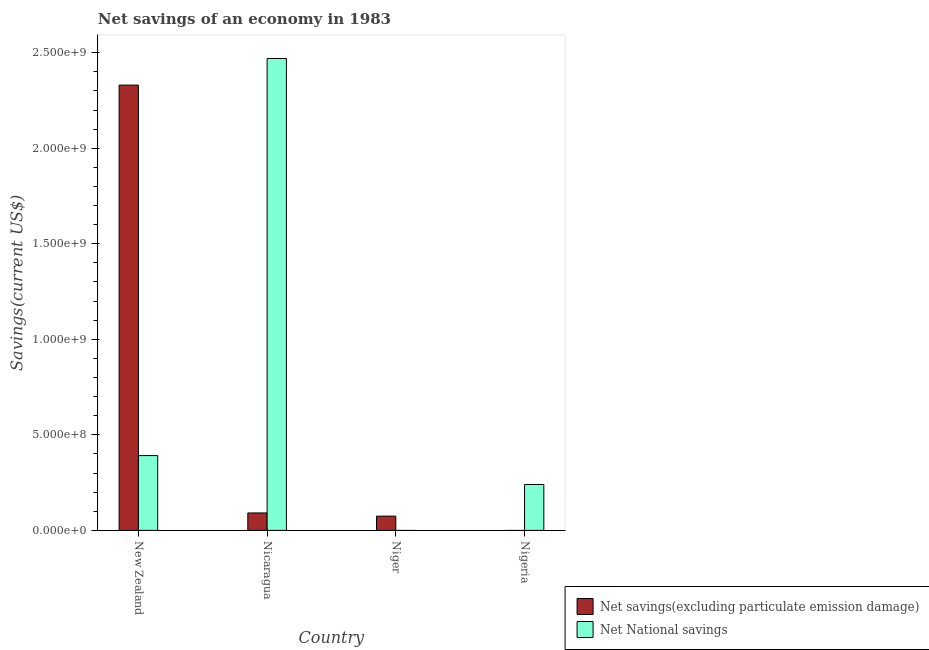Are the number of bars per tick equal to the number of legend labels?
Ensure brevity in your answer.  No. How many bars are there on the 4th tick from the left?
Offer a very short reply. 1. How many bars are there on the 3rd tick from the right?
Offer a very short reply. 2. What is the label of the 4th group of bars from the left?
Your answer should be very brief. Nigeria. What is the net savings(excluding particulate emission damage) in Niger?
Ensure brevity in your answer.  7.47e+07. Across all countries, what is the maximum net national savings?
Make the answer very short. 2.47e+09. In which country was the net national savings maximum?
Offer a terse response. Nicaragua. What is the total net national savings in the graph?
Ensure brevity in your answer.  3.10e+09. What is the difference between the net national savings in Nicaragua and that in Nigeria?
Your answer should be compact. 2.23e+09. What is the difference between the net savings(excluding particulate emission damage) in Niger and the net national savings in New Zealand?
Ensure brevity in your answer.  -3.17e+08. What is the average net national savings per country?
Your answer should be compact. 7.75e+08. What is the difference between the net savings(excluding particulate emission damage) and net national savings in Nicaragua?
Give a very brief answer. -2.38e+09. What is the ratio of the net savings(excluding particulate emission damage) in Nicaragua to that in Niger?
Keep it short and to the point. 1.22. Is the net savings(excluding particulate emission damage) in Nicaragua less than that in Niger?
Make the answer very short. No. What is the difference between the highest and the second highest net national savings?
Keep it short and to the point. 2.08e+09. What is the difference between the highest and the lowest net national savings?
Provide a short and direct response. 2.47e+09. In how many countries, is the net savings(excluding particulate emission damage) greater than the average net savings(excluding particulate emission damage) taken over all countries?
Make the answer very short. 1. How many bars are there?
Keep it short and to the point. 6. What is the difference between two consecutive major ticks on the Y-axis?
Provide a short and direct response. 5.00e+08. Does the graph contain grids?
Your response must be concise. No. What is the title of the graph?
Your answer should be compact. Net savings of an economy in 1983. What is the label or title of the X-axis?
Ensure brevity in your answer.  Country. What is the label or title of the Y-axis?
Provide a succinct answer. Savings(current US$). What is the Savings(current US$) of Net savings(excluding particulate emission damage) in New Zealand?
Provide a succinct answer. 2.33e+09. What is the Savings(current US$) in Net National savings in New Zealand?
Ensure brevity in your answer.  3.92e+08. What is the Savings(current US$) in Net savings(excluding particulate emission damage) in Nicaragua?
Offer a terse response. 9.13e+07. What is the Savings(current US$) in Net National savings in Nicaragua?
Offer a very short reply. 2.47e+09. What is the Savings(current US$) of Net savings(excluding particulate emission damage) in Niger?
Your answer should be very brief. 7.47e+07. What is the Savings(current US$) of Net National savings in Nigeria?
Offer a terse response. 2.40e+08. Across all countries, what is the maximum Savings(current US$) in Net savings(excluding particulate emission damage)?
Offer a very short reply. 2.33e+09. Across all countries, what is the maximum Savings(current US$) in Net National savings?
Provide a short and direct response. 2.47e+09. Across all countries, what is the minimum Savings(current US$) in Net savings(excluding particulate emission damage)?
Your answer should be very brief. 0. Across all countries, what is the minimum Savings(current US$) in Net National savings?
Provide a short and direct response. 0. What is the total Savings(current US$) in Net savings(excluding particulate emission damage) in the graph?
Offer a terse response. 2.50e+09. What is the total Savings(current US$) in Net National savings in the graph?
Your response must be concise. 3.10e+09. What is the difference between the Savings(current US$) of Net savings(excluding particulate emission damage) in New Zealand and that in Nicaragua?
Make the answer very short. 2.24e+09. What is the difference between the Savings(current US$) in Net National savings in New Zealand and that in Nicaragua?
Offer a very short reply. -2.08e+09. What is the difference between the Savings(current US$) of Net savings(excluding particulate emission damage) in New Zealand and that in Niger?
Your answer should be very brief. 2.26e+09. What is the difference between the Savings(current US$) in Net National savings in New Zealand and that in Nigeria?
Your response must be concise. 1.51e+08. What is the difference between the Savings(current US$) in Net savings(excluding particulate emission damage) in Nicaragua and that in Niger?
Give a very brief answer. 1.66e+07. What is the difference between the Savings(current US$) in Net National savings in Nicaragua and that in Nigeria?
Give a very brief answer. 2.23e+09. What is the difference between the Savings(current US$) of Net savings(excluding particulate emission damage) in New Zealand and the Savings(current US$) of Net National savings in Nicaragua?
Offer a very short reply. -1.39e+08. What is the difference between the Savings(current US$) in Net savings(excluding particulate emission damage) in New Zealand and the Savings(current US$) in Net National savings in Nigeria?
Your response must be concise. 2.09e+09. What is the difference between the Savings(current US$) of Net savings(excluding particulate emission damage) in Nicaragua and the Savings(current US$) of Net National savings in Nigeria?
Provide a short and direct response. -1.49e+08. What is the difference between the Savings(current US$) in Net savings(excluding particulate emission damage) in Niger and the Savings(current US$) in Net National savings in Nigeria?
Give a very brief answer. -1.66e+08. What is the average Savings(current US$) in Net savings(excluding particulate emission damage) per country?
Make the answer very short. 6.24e+08. What is the average Savings(current US$) of Net National savings per country?
Provide a short and direct response. 7.75e+08. What is the difference between the Savings(current US$) in Net savings(excluding particulate emission damage) and Savings(current US$) in Net National savings in New Zealand?
Your answer should be very brief. 1.94e+09. What is the difference between the Savings(current US$) of Net savings(excluding particulate emission damage) and Savings(current US$) of Net National savings in Nicaragua?
Offer a terse response. -2.38e+09. What is the ratio of the Savings(current US$) in Net savings(excluding particulate emission damage) in New Zealand to that in Nicaragua?
Offer a very short reply. 25.53. What is the ratio of the Savings(current US$) of Net National savings in New Zealand to that in Nicaragua?
Your answer should be very brief. 0.16. What is the ratio of the Savings(current US$) of Net savings(excluding particulate emission damage) in New Zealand to that in Niger?
Your answer should be very brief. 31.22. What is the ratio of the Savings(current US$) in Net National savings in New Zealand to that in Nigeria?
Provide a short and direct response. 1.63. What is the ratio of the Savings(current US$) of Net savings(excluding particulate emission damage) in Nicaragua to that in Niger?
Ensure brevity in your answer.  1.22. What is the ratio of the Savings(current US$) of Net National savings in Nicaragua to that in Nigeria?
Ensure brevity in your answer.  10.28. What is the difference between the highest and the second highest Savings(current US$) of Net savings(excluding particulate emission damage)?
Your response must be concise. 2.24e+09. What is the difference between the highest and the second highest Savings(current US$) in Net National savings?
Keep it short and to the point. 2.08e+09. What is the difference between the highest and the lowest Savings(current US$) of Net savings(excluding particulate emission damage)?
Offer a very short reply. 2.33e+09. What is the difference between the highest and the lowest Savings(current US$) in Net National savings?
Ensure brevity in your answer.  2.47e+09. 